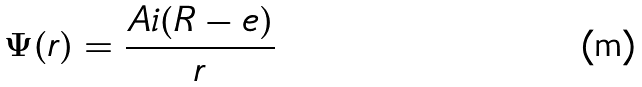<formula> <loc_0><loc_0><loc_500><loc_500>\Psi ( r ) = \frac { A i ( R - e ) } { r }</formula> 